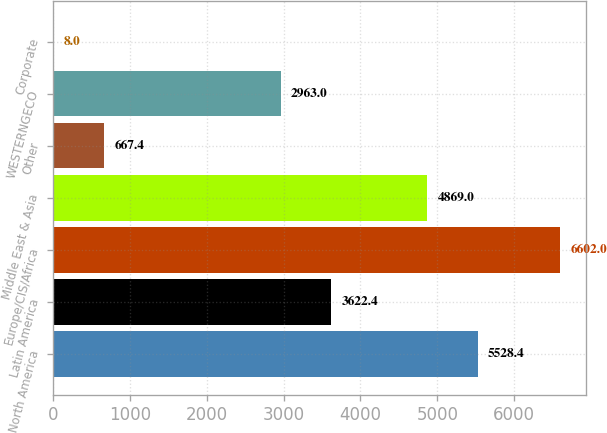Convert chart. <chart><loc_0><loc_0><loc_500><loc_500><bar_chart><fcel>North America<fcel>Latin America<fcel>Europe/CIS/Africa<fcel>Middle East & Asia<fcel>Other<fcel>WESTERNGECO<fcel>Corporate<nl><fcel>5528.4<fcel>3622.4<fcel>6602<fcel>4869<fcel>667.4<fcel>2963<fcel>8<nl></chart> 